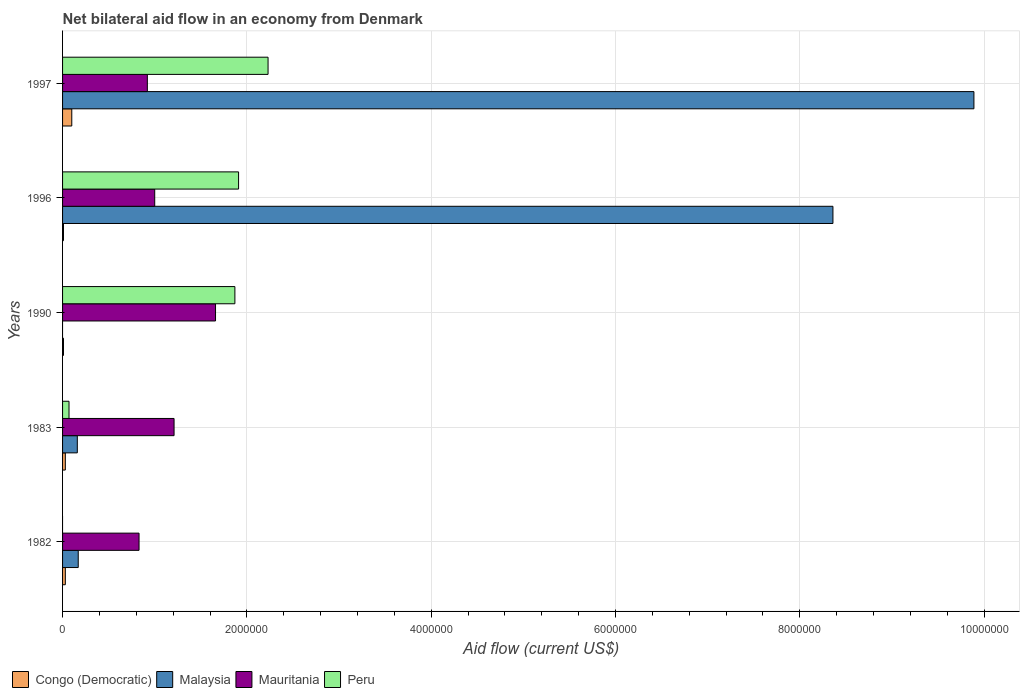How many different coloured bars are there?
Your response must be concise. 4. Are the number of bars per tick equal to the number of legend labels?
Provide a short and direct response. No. Are the number of bars on each tick of the Y-axis equal?
Offer a terse response. No. How many bars are there on the 1st tick from the bottom?
Your response must be concise. 3. What is the label of the 2nd group of bars from the top?
Give a very brief answer. 1996. In how many cases, is the number of bars for a given year not equal to the number of legend labels?
Your response must be concise. 2. What is the net bilateral aid flow in Malaysia in 1990?
Give a very brief answer. 0. Across all years, what is the maximum net bilateral aid flow in Malaysia?
Offer a terse response. 9.89e+06. In which year was the net bilateral aid flow in Congo (Democratic) maximum?
Provide a succinct answer. 1997. What is the total net bilateral aid flow in Peru in the graph?
Offer a terse response. 6.08e+06. What is the difference between the net bilateral aid flow in Mauritania in 1983 and that in 1990?
Provide a short and direct response. -4.50e+05. What is the difference between the net bilateral aid flow in Congo (Democratic) in 1990 and the net bilateral aid flow in Peru in 1997?
Keep it short and to the point. -2.22e+06. What is the average net bilateral aid flow in Mauritania per year?
Keep it short and to the point. 1.12e+06. In the year 1997, what is the difference between the net bilateral aid flow in Congo (Democratic) and net bilateral aid flow in Mauritania?
Make the answer very short. -8.20e+05. What is the ratio of the net bilateral aid flow in Congo (Democratic) in 1990 to that in 1996?
Your answer should be very brief. 1. Is the difference between the net bilateral aid flow in Congo (Democratic) in 1983 and 1997 greater than the difference between the net bilateral aid flow in Mauritania in 1983 and 1997?
Provide a succinct answer. No. What is the difference between the highest and the second highest net bilateral aid flow in Peru?
Your answer should be compact. 3.20e+05. Is the sum of the net bilateral aid flow in Congo (Democratic) in 1990 and 1997 greater than the maximum net bilateral aid flow in Malaysia across all years?
Your answer should be very brief. No. How many bars are there?
Your answer should be compact. 18. How many years are there in the graph?
Provide a short and direct response. 5. Are the values on the major ticks of X-axis written in scientific E-notation?
Ensure brevity in your answer.  No. Does the graph contain any zero values?
Your answer should be very brief. Yes. Does the graph contain grids?
Provide a short and direct response. Yes. How many legend labels are there?
Offer a terse response. 4. What is the title of the graph?
Ensure brevity in your answer.  Net bilateral aid flow in an economy from Denmark. Does "High income" appear as one of the legend labels in the graph?
Keep it short and to the point. No. What is the label or title of the X-axis?
Provide a short and direct response. Aid flow (current US$). What is the Aid flow (current US$) in Congo (Democratic) in 1982?
Your answer should be compact. 3.00e+04. What is the Aid flow (current US$) of Malaysia in 1982?
Offer a terse response. 1.70e+05. What is the Aid flow (current US$) in Mauritania in 1982?
Make the answer very short. 8.30e+05. What is the Aid flow (current US$) of Congo (Democratic) in 1983?
Give a very brief answer. 3.00e+04. What is the Aid flow (current US$) in Mauritania in 1983?
Provide a short and direct response. 1.21e+06. What is the Aid flow (current US$) of Mauritania in 1990?
Your response must be concise. 1.66e+06. What is the Aid flow (current US$) of Peru in 1990?
Provide a short and direct response. 1.87e+06. What is the Aid flow (current US$) in Congo (Democratic) in 1996?
Your answer should be compact. 10000. What is the Aid flow (current US$) of Malaysia in 1996?
Make the answer very short. 8.36e+06. What is the Aid flow (current US$) of Mauritania in 1996?
Ensure brevity in your answer.  1.00e+06. What is the Aid flow (current US$) of Peru in 1996?
Make the answer very short. 1.91e+06. What is the Aid flow (current US$) of Malaysia in 1997?
Ensure brevity in your answer.  9.89e+06. What is the Aid flow (current US$) in Mauritania in 1997?
Your answer should be compact. 9.20e+05. What is the Aid flow (current US$) in Peru in 1997?
Your answer should be compact. 2.23e+06. Across all years, what is the maximum Aid flow (current US$) in Malaysia?
Offer a very short reply. 9.89e+06. Across all years, what is the maximum Aid flow (current US$) in Mauritania?
Ensure brevity in your answer.  1.66e+06. Across all years, what is the maximum Aid flow (current US$) in Peru?
Provide a succinct answer. 2.23e+06. Across all years, what is the minimum Aid flow (current US$) of Congo (Democratic)?
Offer a terse response. 10000. Across all years, what is the minimum Aid flow (current US$) of Malaysia?
Provide a short and direct response. 0. Across all years, what is the minimum Aid flow (current US$) of Mauritania?
Keep it short and to the point. 8.30e+05. Across all years, what is the minimum Aid flow (current US$) in Peru?
Provide a succinct answer. 0. What is the total Aid flow (current US$) in Malaysia in the graph?
Provide a succinct answer. 1.86e+07. What is the total Aid flow (current US$) in Mauritania in the graph?
Keep it short and to the point. 5.62e+06. What is the total Aid flow (current US$) in Peru in the graph?
Offer a terse response. 6.08e+06. What is the difference between the Aid flow (current US$) of Malaysia in 1982 and that in 1983?
Provide a succinct answer. 10000. What is the difference between the Aid flow (current US$) in Mauritania in 1982 and that in 1983?
Make the answer very short. -3.80e+05. What is the difference between the Aid flow (current US$) of Mauritania in 1982 and that in 1990?
Offer a terse response. -8.30e+05. What is the difference between the Aid flow (current US$) in Malaysia in 1982 and that in 1996?
Your response must be concise. -8.19e+06. What is the difference between the Aid flow (current US$) in Mauritania in 1982 and that in 1996?
Give a very brief answer. -1.70e+05. What is the difference between the Aid flow (current US$) of Malaysia in 1982 and that in 1997?
Your answer should be very brief. -9.72e+06. What is the difference between the Aid flow (current US$) in Mauritania in 1982 and that in 1997?
Ensure brevity in your answer.  -9.00e+04. What is the difference between the Aid flow (current US$) in Congo (Democratic) in 1983 and that in 1990?
Keep it short and to the point. 2.00e+04. What is the difference between the Aid flow (current US$) of Mauritania in 1983 and that in 1990?
Your answer should be very brief. -4.50e+05. What is the difference between the Aid flow (current US$) in Peru in 1983 and that in 1990?
Provide a succinct answer. -1.80e+06. What is the difference between the Aid flow (current US$) of Congo (Democratic) in 1983 and that in 1996?
Provide a short and direct response. 2.00e+04. What is the difference between the Aid flow (current US$) of Malaysia in 1983 and that in 1996?
Give a very brief answer. -8.20e+06. What is the difference between the Aid flow (current US$) of Mauritania in 1983 and that in 1996?
Give a very brief answer. 2.10e+05. What is the difference between the Aid flow (current US$) of Peru in 1983 and that in 1996?
Offer a terse response. -1.84e+06. What is the difference between the Aid flow (current US$) of Malaysia in 1983 and that in 1997?
Make the answer very short. -9.73e+06. What is the difference between the Aid flow (current US$) in Peru in 1983 and that in 1997?
Keep it short and to the point. -2.16e+06. What is the difference between the Aid flow (current US$) of Congo (Democratic) in 1990 and that in 1996?
Provide a succinct answer. 0. What is the difference between the Aid flow (current US$) of Mauritania in 1990 and that in 1996?
Offer a terse response. 6.60e+05. What is the difference between the Aid flow (current US$) in Congo (Democratic) in 1990 and that in 1997?
Give a very brief answer. -9.00e+04. What is the difference between the Aid flow (current US$) in Mauritania in 1990 and that in 1997?
Provide a succinct answer. 7.40e+05. What is the difference between the Aid flow (current US$) in Peru in 1990 and that in 1997?
Offer a very short reply. -3.60e+05. What is the difference between the Aid flow (current US$) in Congo (Democratic) in 1996 and that in 1997?
Provide a short and direct response. -9.00e+04. What is the difference between the Aid flow (current US$) of Malaysia in 1996 and that in 1997?
Your response must be concise. -1.53e+06. What is the difference between the Aid flow (current US$) of Peru in 1996 and that in 1997?
Your answer should be very brief. -3.20e+05. What is the difference between the Aid flow (current US$) in Congo (Democratic) in 1982 and the Aid flow (current US$) in Mauritania in 1983?
Your answer should be compact. -1.18e+06. What is the difference between the Aid flow (current US$) of Congo (Democratic) in 1982 and the Aid flow (current US$) of Peru in 1983?
Your answer should be very brief. -4.00e+04. What is the difference between the Aid flow (current US$) of Malaysia in 1982 and the Aid flow (current US$) of Mauritania in 1983?
Offer a terse response. -1.04e+06. What is the difference between the Aid flow (current US$) in Malaysia in 1982 and the Aid flow (current US$) in Peru in 1983?
Your answer should be compact. 1.00e+05. What is the difference between the Aid flow (current US$) in Mauritania in 1982 and the Aid flow (current US$) in Peru in 1983?
Your answer should be very brief. 7.60e+05. What is the difference between the Aid flow (current US$) in Congo (Democratic) in 1982 and the Aid flow (current US$) in Mauritania in 1990?
Keep it short and to the point. -1.63e+06. What is the difference between the Aid flow (current US$) of Congo (Democratic) in 1982 and the Aid flow (current US$) of Peru in 1990?
Keep it short and to the point. -1.84e+06. What is the difference between the Aid flow (current US$) of Malaysia in 1982 and the Aid flow (current US$) of Mauritania in 1990?
Offer a very short reply. -1.49e+06. What is the difference between the Aid flow (current US$) of Malaysia in 1982 and the Aid flow (current US$) of Peru in 1990?
Keep it short and to the point. -1.70e+06. What is the difference between the Aid flow (current US$) of Mauritania in 1982 and the Aid flow (current US$) of Peru in 1990?
Your answer should be compact. -1.04e+06. What is the difference between the Aid flow (current US$) in Congo (Democratic) in 1982 and the Aid flow (current US$) in Malaysia in 1996?
Provide a short and direct response. -8.33e+06. What is the difference between the Aid flow (current US$) of Congo (Democratic) in 1982 and the Aid flow (current US$) of Mauritania in 1996?
Your answer should be very brief. -9.70e+05. What is the difference between the Aid flow (current US$) of Congo (Democratic) in 1982 and the Aid flow (current US$) of Peru in 1996?
Keep it short and to the point. -1.88e+06. What is the difference between the Aid flow (current US$) of Malaysia in 1982 and the Aid flow (current US$) of Mauritania in 1996?
Give a very brief answer. -8.30e+05. What is the difference between the Aid flow (current US$) in Malaysia in 1982 and the Aid flow (current US$) in Peru in 1996?
Your answer should be compact. -1.74e+06. What is the difference between the Aid flow (current US$) in Mauritania in 1982 and the Aid flow (current US$) in Peru in 1996?
Provide a succinct answer. -1.08e+06. What is the difference between the Aid flow (current US$) of Congo (Democratic) in 1982 and the Aid flow (current US$) of Malaysia in 1997?
Keep it short and to the point. -9.86e+06. What is the difference between the Aid flow (current US$) of Congo (Democratic) in 1982 and the Aid flow (current US$) of Mauritania in 1997?
Offer a terse response. -8.90e+05. What is the difference between the Aid flow (current US$) of Congo (Democratic) in 1982 and the Aid flow (current US$) of Peru in 1997?
Your answer should be very brief. -2.20e+06. What is the difference between the Aid flow (current US$) of Malaysia in 1982 and the Aid flow (current US$) of Mauritania in 1997?
Ensure brevity in your answer.  -7.50e+05. What is the difference between the Aid flow (current US$) in Malaysia in 1982 and the Aid flow (current US$) in Peru in 1997?
Your response must be concise. -2.06e+06. What is the difference between the Aid flow (current US$) in Mauritania in 1982 and the Aid flow (current US$) in Peru in 1997?
Your answer should be compact. -1.40e+06. What is the difference between the Aid flow (current US$) of Congo (Democratic) in 1983 and the Aid flow (current US$) of Mauritania in 1990?
Make the answer very short. -1.63e+06. What is the difference between the Aid flow (current US$) in Congo (Democratic) in 1983 and the Aid flow (current US$) in Peru in 1990?
Offer a very short reply. -1.84e+06. What is the difference between the Aid flow (current US$) in Malaysia in 1983 and the Aid flow (current US$) in Mauritania in 1990?
Provide a short and direct response. -1.50e+06. What is the difference between the Aid flow (current US$) in Malaysia in 1983 and the Aid flow (current US$) in Peru in 1990?
Make the answer very short. -1.71e+06. What is the difference between the Aid flow (current US$) of Mauritania in 1983 and the Aid flow (current US$) of Peru in 1990?
Give a very brief answer. -6.60e+05. What is the difference between the Aid flow (current US$) of Congo (Democratic) in 1983 and the Aid flow (current US$) of Malaysia in 1996?
Your answer should be compact. -8.33e+06. What is the difference between the Aid flow (current US$) in Congo (Democratic) in 1983 and the Aid flow (current US$) in Mauritania in 1996?
Your answer should be very brief. -9.70e+05. What is the difference between the Aid flow (current US$) in Congo (Democratic) in 1983 and the Aid flow (current US$) in Peru in 1996?
Make the answer very short. -1.88e+06. What is the difference between the Aid flow (current US$) in Malaysia in 1983 and the Aid flow (current US$) in Mauritania in 1996?
Give a very brief answer. -8.40e+05. What is the difference between the Aid flow (current US$) in Malaysia in 1983 and the Aid flow (current US$) in Peru in 1996?
Ensure brevity in your answer.  -1.75e+06. What is the difference between the Aid flow (current US$) of Mauritania in 1983 and the Aid flow (current US$) of Peru in 1996?
Offer a very short reply. -7.00e+05. What is the difference between the Aid flow (current US$) of Congo (Democratic) in 1983 and the Aid flow (current US$) of Malaysia in 1997?
Provide a short and direct response. -9.86e+06. What is the difference between the Aid flow (current US$) in Congo (Democratic) in 1983 and the Aid flow (current US$) in Mauritania in 1997?
Provide a short and direct response. -8.90e+05. What is the difference between the Aid flow (current US$) in Congo (Democratic) in 1983 and the Aid flow (current US$) in Peru in 1997?
Ensure brevity in your answer.  -2.20e+06. What is the difference between the Aid flow (current US$) of Malaysia in 1983 and the Aid flow (current US$) of Mauritania in 1997?
Provide a succinct answer. -7.60e+05. What is the difference between the Aid flow (current US$) in Malaysia in 1983 and the Aid flow (current US$) in Peru in 1997?
Keep it short and to the point. -2.07e+06. What is the difference between the Aid flow (current US$) of Mauritania in 1983 and the Aid flow (current US$) of Peru in 1997?
Provide a succinct answer. -1.02e+06. What is the difference between the Aid flow (current US$) in Congo (Democratic) in 1990 and the Aid flow (current US$) in Malaysia in 1996?
Your answer should be compact. -8.35e+06. What is the difference between the Aid flow (current US$) of Congo (Democratic) in 1990 and the Aid flow (current US$) of Mauritania in 1996?
Make the answer very short. -9.90e+05. What is the difference between the Aid flow (current US$) in Congo (Democratic) in 1990 and the Aid flow (current US$) in Peru in 1996?
Your response must be concise. -1.90e+06. What is the difference between the Aid flow (current US$) of Congo (Democratic) in 1990 and the Aid flow (current US$) of Malaysia in 1997?
Offer a terse response. -9.88e+06. What is the difference between the Aid flow (current US$) in Congo (Democratic) in 1990 and the Aid flow (current US$) in Mauritania in 1997?
Your answer should be very brief. -9.10e+05. What is the difference between the Aid flow (current US$) of Congo (Democratic) in 1990 and the Aid flow (current US$) of Peru in 1997?
Your answer should be compact. -2.22e+06. What is the difference between the Aid flow (current US$) in Mauritania in 1990 and the Aid flow (current US$) in Peru in 1997?
Make the answer very short. -5.70e+05. What is the difference between the Aid flow (current US$) of Congo (Democratic) in 1996 and the Aid flow (current US$) of Malaysia in 1997?
Offer a very short reply. -9.88e+06. What is the difference between the Aid flow (current US$) of Congo (Democratic) in 1996 and the Aid flow (current US$) of Mauritania in 1997?
Offer a terse response. -9.10e+05. What is the difference between the Aid flow (current US$) of Congo (Democratic) in 1996 and the Aid flow (current US$) of Peru in 1997?
Keep it short and to the point. -2.22e+06. What is the difference between the Aid flow (current US$) of Malaysia in 1996 and the Aid flow (current US$) of Mauritania in 1997?
Make the answer very short. 7.44e+06. What is the difference between the Aid flow (current US$) in Malaysia in 1996 and the Aid flow (current US$) in Peru in 1997?
Keep it short and to the point. 6.13e+06. What is the difference between the Aid flow (current US$) of Mauritania in 1996 and the Aid flow (current US$) of Peru in 1997?
Keep it short and to the point. -1.23e+06. What is the average Aid flow (current US$) in Congo (Democratic) per year?
Provide a short and direct response. 3.60e+04. What is the average Aid flow (current US$) in Malaysia per year?
Make the answer very short. 3.72e+06. What is the average Aid flow (current US$) of Mauritania per year?
Offer a terse response. 1.12e+06. What is the average Aid flow (current US$) of Peru per year?
Give a very brief answer. 1.22e+06. In the year 1982, what is the difference between the Aid flow (current US$) in Congo (Democratic) and Aid flow (current US$) in Mauritania?
Give a very brief answer. -8.00e+05. In the year 1982, what is the difference between the Aid flow (current US$) of Malaysia and Aid flow (current US$) of Mauritania?
Your answer should be very brief. -6.60e+05. In the year 1983, what is the difference between the Aid flow (current US$) in Congo (Democratic) and Aid flow (current US$) in Mauritania?
Your response must be concise. -1.18e+06. In the year 1983, what is the difference between the Aid flow (current US$) of Congo (Democratic) and Aid flow (current US$) of Peru?
Your answer should be very brief. -4.00e+04. In the year 1983, what is the difference between the Aid flow (current US$) in Malaysia and Aid flow (current US$) in Mauritania?
Give a very brief answer. -1.05e+06. In the year 1983, what is the difference between the Aid flow (current US$) of Mauritania and Aid flow (current US$) of Peru?
Provide a succinct answer. 1.14e+06. In the year 1990, what is the difference between the Aid flow (current US$) of Congo (Democratic) and Aid flow (current US$) of Mauritania?
Ensure brevity in your answer.  -1.65e+06. In the year 1990, what is the difference between the Aid flow (current US$) of Congo (Democratic) and Aid flow (current US$) of Peru?
Ensure brevity in your answer.  -1.86e+06. In the year 1990, what is the difference between the Aid flow (current US$) of Mauritania and Aid flow (current US$) of Peru?
Offer a terse response. -2.10e+05. In the year 1996, what is the difference between the Aid flow (current US$) of Congo (Democratic) and Aid flow (current US$) of Malaysia?
Give a very brief answer. -8.35e+06. In the year 1996, what is the difference between the Aid flow (current US$) of Congo (Democratic) and Aid flow (current US$) of Mauritania?
Offer a very short reply. -9.90e+05. In the year 1996, what is the difference between the Aid flow (current US$) in Congo (Democratic) and Aid flow (current US$) in Peru?
Your answer should be very brief. -1.90e+06. In the year 1996, what is the difference between the Aid flow (current US$) in Malaysia and Aid flow (current US$) in Mauritania?
Keep it short and to the point. 7.36e+06. In the year 1996, what is the difference between the Aid flow (current US$) of Malaysia and Aid flow (current US$) of Peru?
Ensure brevity in your answer.  6.45e+06. In the year 1996, what is the difference between the Aid flow (current US$) of Mauritania and Aid flow (current US$) of Peru?
Ensure brevity in your answer.  -9.10e+05. In the year 1997, what is the difference between the Aid flow (current US$) in Congo (Democratic) and Aid flow (current US$) in Malaysia?
Offer a terse response. -9.79e+06. In the year 1997, what is the difference between the Aid flow (current US$) in Congo (Democratic) and Aid flow (current US$) in Mauritania?
Offer a terse response. -8.20e+05. In the year 1997, what is the difference between the Aid flow (current US$) in Congo (Democratic) and Aid flow (current US$) in Peru?
Offer a terse response. -2.13e+06. In the year 1997, what is the difference between the Aid flow (current US$) of Malaysia and Aid flow (current US$) of Mauritania?
Offer a very short reply. 8.97e+06. In the year 1997, what is the difference between the Aid flow (current US$) of Malaysia and Aid flow (current US$) of Peru?
Ensure brevity in your answer.  7.66e+06. In the year 1997, what is the difference between the Aid flow (current US$) in Mauritania and Aid flow (current US$) in Peru?
Provide a short and direct response. -1.31e+06. What is the ratio of the Aid flow (current US$) in Congo (Democratic) in 1982 to that in 1983?
Provide a succinct answer. 1. What is the ratio of the Aid flow (current US$) of Malaysia in 1982 to that in 1983?
Make the answer very short. 1.06. What is the ratio of the Aid flow (current US$) of Mauritania in 1982 to that in 1983?
Your answer should be compact. 0.69. What is the ratio of the Aid flow (current US$) of Malaysia in 1982 to that in 1996?
Keep it short and to the point. 0.02. What is the ratio of the Aid flow (current US$) of Mauritania in 1982 to that in 1996?
Provide a short and direct response. 0.83. What is the ratio of the Aid flow (current US$) in Congo (Democratic) in 1982 to that in 1997?
Keep it short and to the point. 0.3. What is the ratio of the Aid flow (current US$) in Malaysia in 1982 to that in 1997?
Provide a succinct answer. 0.02. What is the ratio of the Aid flow (current US$) of Mauritania in 1982 to that in 1997?
Provide a short and direct response. 0.9. What is the ratio of the Aid flow (current US$) of Mauritania in 1983 to that in 1990?
Provide a short and direct response. 0.73. What is the ratio of the Aid flow (current US$) of Peru in 1983 to that in 1990?
Provide a succinct answer. 0.04. What is the ratio of the Aid flow (current US$) of Congo (Democratic) in 1983 to that in 1996?
Your answer should be very brief. 3. What is the ratio of the Aid flow (current US$) of Malaysia in 1983 to that in 1996?
Your answer should be very brief. 0.02. What is the ratio of the Aid flow (current US$) in Mauritania in 1983 to that in 1996?
Provide a succinct answer. 1.21. What is the ratio of the Aid flow (current US$) of Peru in 1983 to that in 1996?
Offer a terse response. 0.04. What is the ratio of the Aid flow (current US$) in Malaysia in 1983 to that in 1997?
Offer a terse response. 0.02. What is the ratio of the Aid flow (current US$) in Mauritania in 1983 to that in 1997?
Provide a short and direct response. 1.32. What is the ratio of the Aid flow (current US$) of Peru in 1983 to that in 1997?
Offer a terse response. 0.03. What is the ratio of the Aid flow (current US$) in Congo (Democratic) in 1990 to that in 1996?
Make the answer very short. 1. What is the ratio of the Aid flow (current US$) in Mauritania in 1990 to that in 1996?
Give a very brief answer. 1.66. What is the ratio of the Aid flow (current US$) of Peru in 1990 to that in 1996?
Offer a very short reply. 0.98. What is the ratio of the Aid flow (current US$) in Congo (Democratic) in 1990 to that in 1997?
Provide a succinct answer. 0.1. What is the ratio of the Aid flow (current US$) in Mauritania in 1990 to that in 1997?
Your response must be concise. 1.8. What is the ratio of the Aid flow (current US$) in Peru in 1990 to that in 1997?
Keep it short and to the point. 0.84. What is the ratio of the Aid flow (current US$) of Congo (Democratic) in 1996 to that in 1997?
Provide a succinct answer. 0.1. What is the ratio of the Aid flow (current US$) of Malaysia in 1996 to that in 1997?
Provide a short and direct response. 0.85. What is the ratio of the Aid flow (current US$) in Mauritania in 1996 to that in 1997?
Offer a very short reply. 1.09. What is the ratio of the Aid flow (current US$) in Peru in 1996 to that in 1997?
Keep it short and to the point. 0.86. What is the difference between the highest and the second highest Aid flow (current US$) in Congo (Democratic)?
Provide a succinct answer. 7.00e+04. What is the difference between the highest and the second highest Aid flow (current US$) in Malaysia?
Your response must be concise. 1.53e+06. What is the difference between the highest and the lowest Aid flow (current US$) in Congo (Democratic)?
Your answer should be compact. 9.00e+04. What is the difference between the highest and the lowest Aid flow (current US$) of Malaysia?
Ensure brevity in your answer.  9.89e+06. What is the difference between the highest and the lowest Aid flow (current US$) of Mauritania?
Ensure brevity in your answer.  8.30e+05. What is the difference between the highest and the lowest Aid flow (current US$) of Peru?
Your response must be concise. 2.23e+06. 